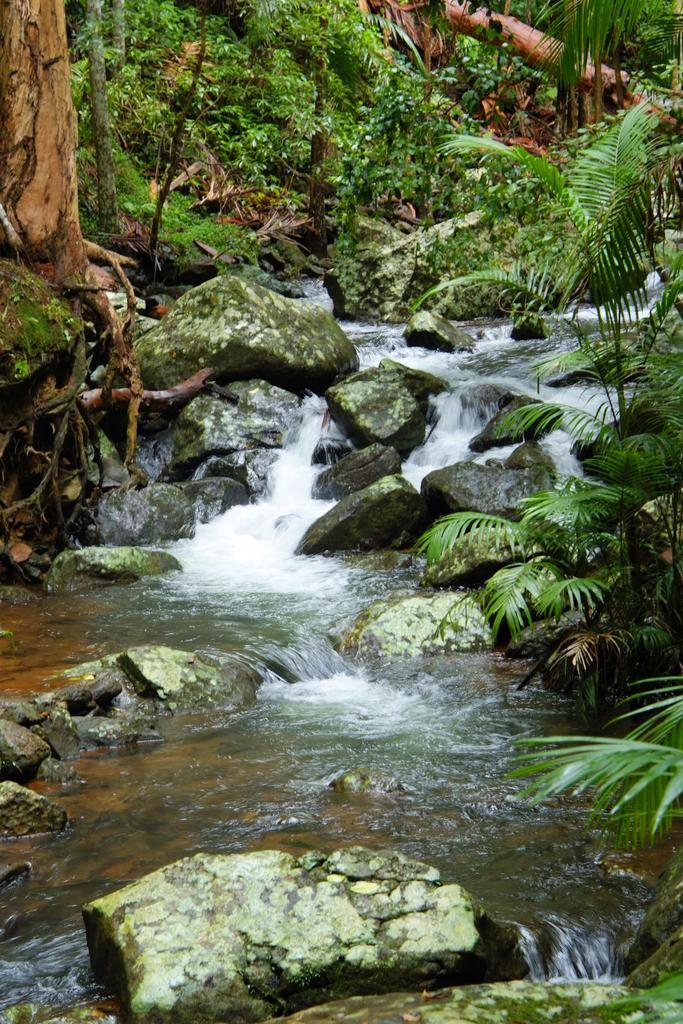Could you give a brief overview of what you see in this image? Here we can see water is flowing and there are stones in the water. In the background there are trees and plants. 